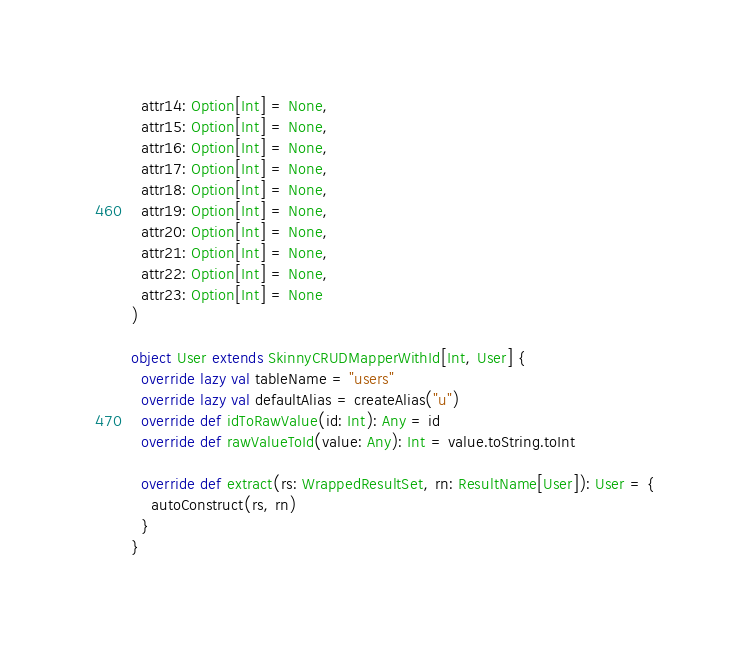<code> <loc_0><loc_0><loc_500><loc_500><_Scala_>  attr14: Option[Int] = None,
  attr15: Option[Int] = None,
  attr16: Option[Int] = None,
  attr17: Option[Int] = None,
  attr18: Option[Int] = None,
  attr19: Option[Int] = None,
  attr20: Option[Int] = None,
  attr21: Option[Int] = None,
  attr22: Option[Int] = None,
  attr23: Option[Int] = None
)

object User extends SkinnyCRUDMapperWithId[Int, User] {
  override lazy val tableName = "users"
  override lazy val defaultAlias = createAlias("u")
  override def idToRawValue(id: Int): Any = id
  override def rawValueToId(value: Any): Int = value.toString.toInt

  override def extract(rs: WrappedResultSet, rn: ResultName[User]): User = {
    autoConstruct(rs, rn)
  }
}
</code> 